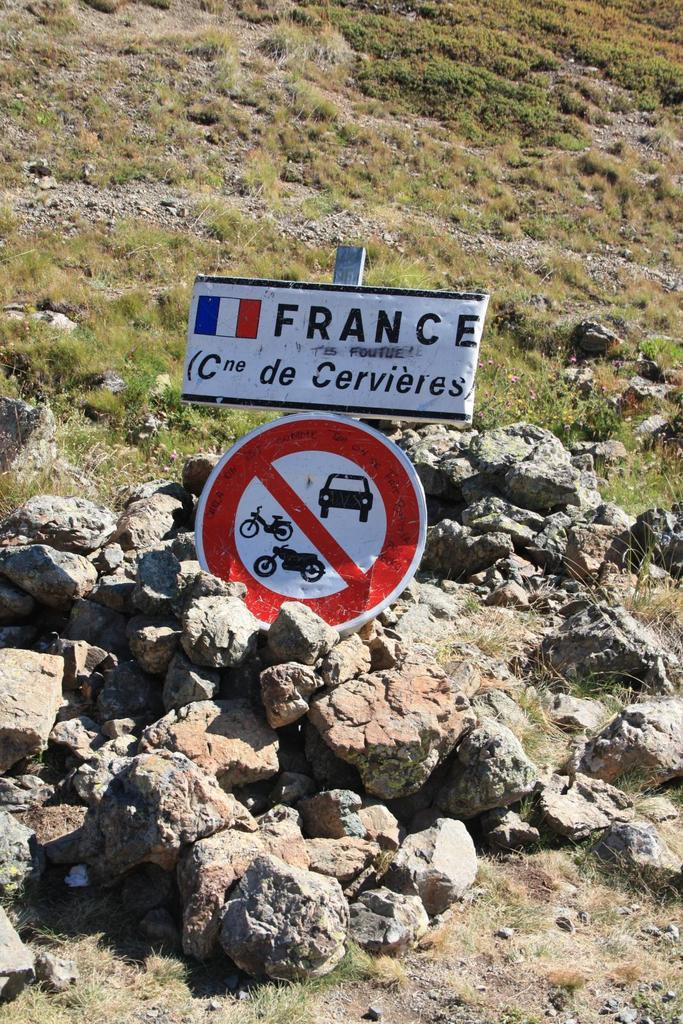Provide a one-sentence caption for the provided image. A mount of dirt with a french sign saying no vehicles. 